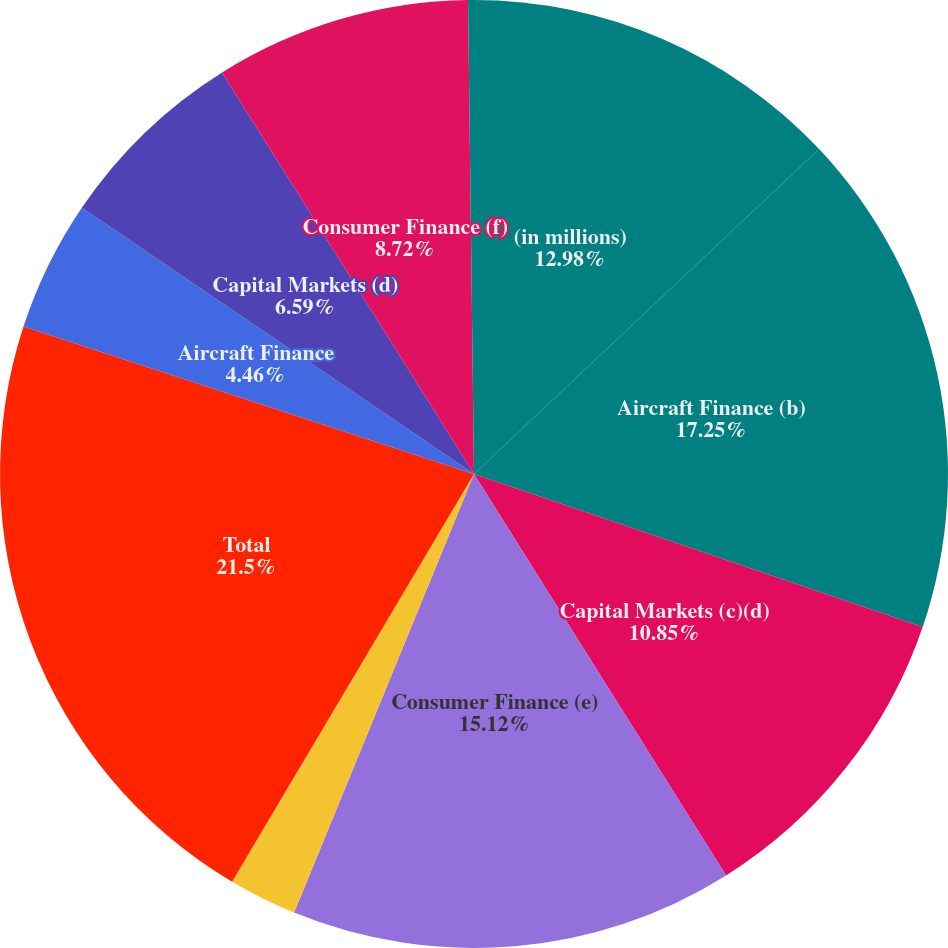Convert chart. <chart><loc_0><loc_0><loc_500><loc_500><pie_chart><fcel>(in millions)<fcel>Aircraft Finance (b)<fcel>Capital Markets (c)(d)<fcel>Consumer Finance (e)<fcel>Other<fcel>Total<fcel>Aircraft Finance<fcel>Capital Markets (d)<fcel>Consumer Finance (f)<fcel>Other including intercompany<nl><fcel>12.98%<fcel>17.25%<fcel>10.85%<fcel>15.12%<fcel>2.33%<fcel>21.51%<fcel>4.46%<fcel>6.59%<fcel>8.72%<fcel>0.2%<nl></chart> 